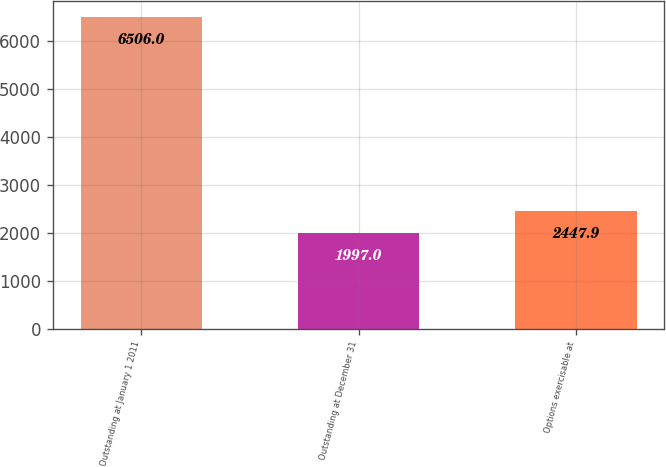Convert chart to OTSL. <chart><loc_0><loc_0><loc_500><loc_500><bar_chart><fcel>Outstanding at January 1 2011<fcel>Outstanding at December 31<fcel>Options exercisable at<nl><fcel>6506<fcel>1997<fcel>2447.9<nl></chart> 